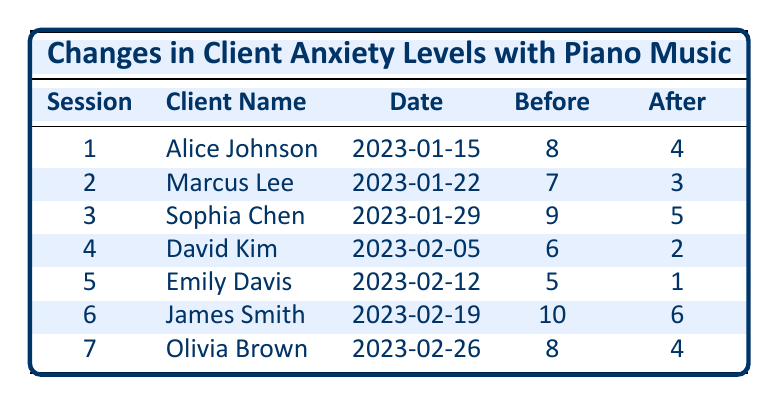What was Alice Johnson's anxiety level before the session? The table shows Alice Johnson's anxiety level before the session, which is listed in the "Before" column for Session 1. The value provided is 8.
Answer: 8 What was the date of the session for Marcus Lee? The table lists the date for each session in the "Date" column. For Marcus Lee, this is Session 2, which occurred on January 22, 2023.
Answer: 2023-01-22 Who had the highest anxiety level before the therapy session? To find the highest anxiety level before the session, we compare the values in the "Before" column. The highest value is 10, associated with James Smith.
Answer: James Smith What is the average anxiety level after the sessions? To calculate the average, we sum the values in the "After" column: 4 + 3 + 5 + 2 + 1 + 6 + 4 = 25. There are 7 sessions, so we divide the total by 7: 25/7 ≈ 3.57.
Answer: 3.57 Did any client reduce their anxiety level to zero after the session? By examining the "After" column, we see the lowest value is 1 (Emily Davis), and no value is zero, indicating that no client reached zero anxiety level after the session.
Answer: No What was the total reduction in anxiety levels for all clients combined? First, we find the total anxiety before and after the sessions. The total before is 8 + 7 + 9 + 6 + 5 + 10 + 8 = 53, and after is 4 + 3 + 5 + 2 + 1 + 6 + 4 = 25. The reduction is 53 - 25 = 28.
Answer: 28 How many clients had an anxiety level over 7 before the therapy sessions? We look at the "Before" column and see that Alice Johnson (8), Marcus Lee (7), and James Smith (10) had anxiety levels over 7. Counting these, we find there are 4 clients.
Answer: 4 What is the anxiety reduction rate for David Kim? David Kim's anxiety level before is 6 and after is 2. The reduction is 6 - 2 = 4. To find the rate, we divide by the initial level: 4/6 ≈ 0.67 or 67%.
Answer: 67% Which client's anxiety level decreased the most? We calculate the reductions for each client: Alice (4), Marcus (4), Sophia (4), David (4), Emily (4), James (4), and Olivia (4). Each had a reduction of 4. Since all had the same reduction, they are tied.
Answer: All of them (4 reduction each) 